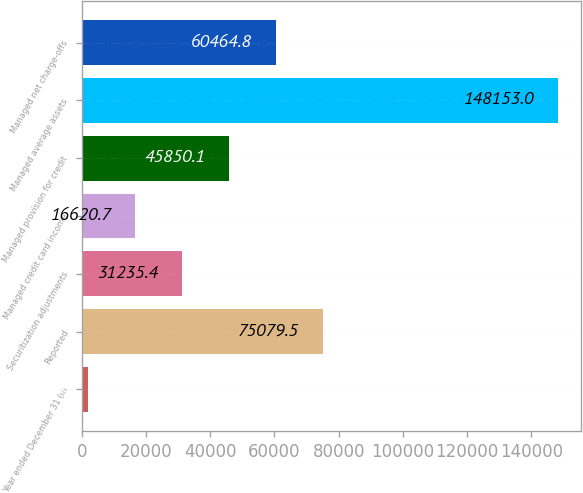<chart> <loc_0><loc_0><loc_500><loc_500><bar_chart><fcel>Year ended December 31 (in<fcel>Reported<fcel>Securitization adjustments<fcel>Managed credit card income<fcel>Managed provision for credit<fcel>Managed average assets<fcel>Managed net charge-offs<nl><fcel>2006<fcel>75079.5<fcel>31235.4<fcel>16620.7<fcel>45850.1<fcel>148153<fcel>60464.8<nl></chart> 